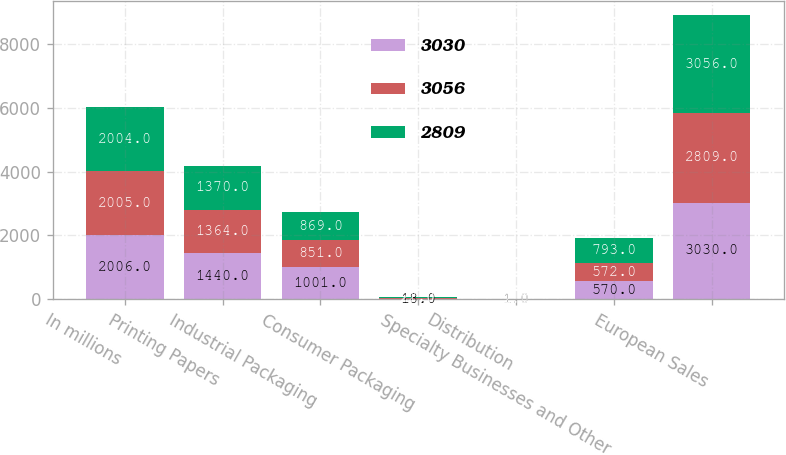Convert chart to OTSL. <chart><loc_0><loc_0><loc_500><loc_500><stacked_bar_chart><ecel><fcel>In millions<fcel>Printing Papers<fcel>Industrial Packaging<fcel>Consumer Packaging<fcel>Distribution<fcel>Specialty Businesses and Other<fcel>European Sales<nl><fcel>3030<fcel>2006<fcel>1440<fcel>1001<fcel>18<fcel>1<fcel>570<fcel>3030<nl><fcel>3056<fcel>2005<fcel>1364<fcel>851<fcel>21<fcel>1<fcel>572<fcel>2809<nl><fcel>2809<fcel>2004<fcel>1370<fcel>869<fcel>22<fcel>2<fcel>793<fcel>3056<nl></chart> 